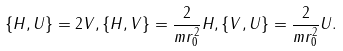<formula> <loc_0><loc_0><loc_500><loc_500>\{ H , U \} = 2 V , \{ H , V \} = \frac { 2 } { m r _ { 0 } ^ { 2 } } H , \{ V , U \} = \frac { 2 } { m r _ { 0 } ^ { 2 } } U .</formula> 